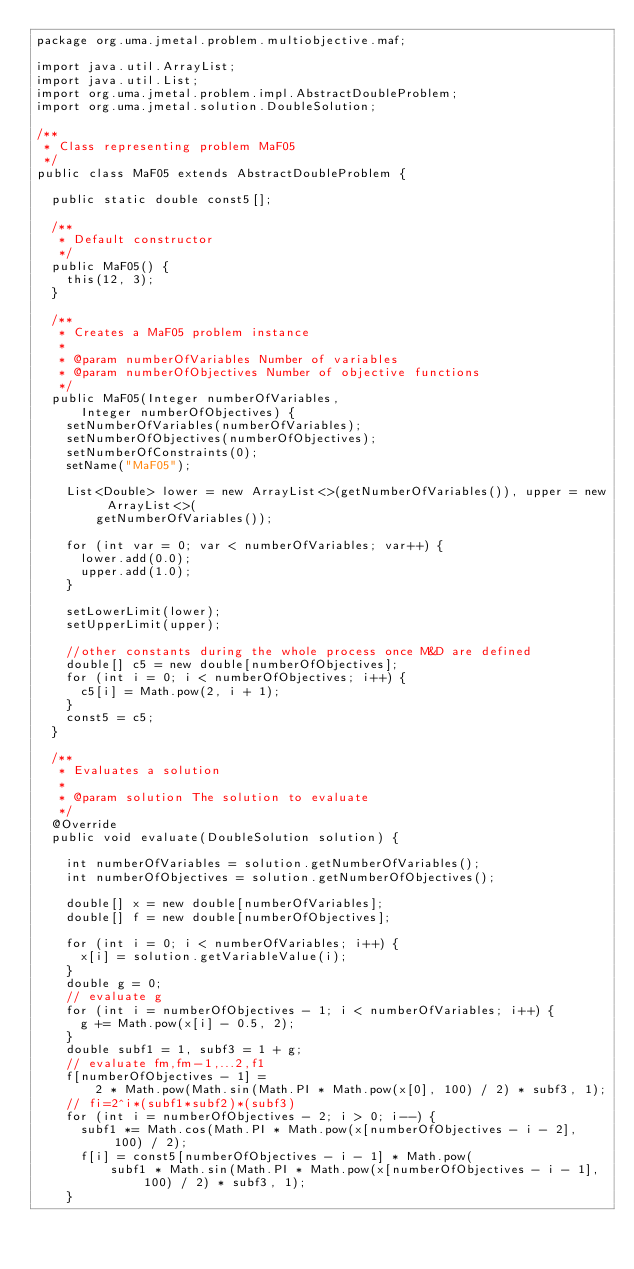Convert code to text. <code><loc_0><loc_0><loc_500><loc_500><_Java_>package org.uma.jmetal.problem.multiobjective.maf;

import java.util.ArrayList;
import java.util.List;
import org.uma.jmetal.problem.impl.AbstractDoubleProblem;
import org.uma.jmetal.solution.DoubleSolution;

/**
 * Class representing problem MaF05
 */
public class MaF05 extends AbstractDoubleProblem {

  public static double const5[];

  /**
   * Default constructor
   */
  public MaF05() {
    this(12, 3);
  }

  /**
   * Creates a MaF05 problem instance
   *
   * @param numberOfVariables Number of variables
   * @param numberOfObjectives Number of objective functions
   */
  public MaF05(Integer numberOfVariables,
      Integer numberOfObjectives) {
    setNumberOfVariables(numberOfVariables);
    setNumberOfObjectives(numberOfObjectives);
    setNumberOfConstraints(0);
    setName("MaF05");

    List<Double> lower = new ArrayList<>(getNumberOfVariables()), upper = new ArrayList<>(
        getNumberOfVariables());

    for (int var = 0; var < numberOfVariables; var++) {
      lower.add(0.0);
      upper.add(1.0);
    }

    setLowerLimit(lower);
    setUpperLimit(upper);

    //other constants during the whole process once M&D are defined
    double[] c5 = new double[numberOfObjectives];
    for (int i = 0; i < numberOfObjectives; i++) {
      c5[i] = Math.pow(2, i + 1);
    }
    const5 = c5;
  }

  /**
   * Evaluates a solution
   *
   * @param solution The solution to evaluate
   */
  @Override
  public void evaluate(DoubleSolution solution) {

    int numberOfVariables = solution.getNumberOfVariables();
    int numberOfObjectives = solution.getNumberOfObjectives();

    double[] x = new double[numberOfVariables];
    double[] f = new double[numberOfObjectives];

    for (int i = 0; i < numberOfVariables; i++) {
      x[i] = solution.getVariableValue(i);
    }
    double g = 0;
    // evaluate g
    for (int i = numberOfObjectives - 1; i < numberOfVariables; i++) {
      g += Math.pow(x[i] - 0.5, 2);
    }
    double subf1 = 1, subf3 = 1 + g;
    // evaluate fm,fm-1,...2,f1
    f[numberOfObjectives - 1] =
        2 * Math.pow(Math.sin(Math.PI * Math.pow(x[0], 100) / 2) * subf3, 1);
    // fi=2^i*(subf1*subf2)*(subf3)
    for (int i = numberOfObjectives - 2; i > 0; i--) {
      subf1 *= Math.cos(Math.PI * Math.pow(x[numberOfObjectives - i - 2], 100) / 2);
      f[i] = const5[numberOfObjectives - i - 1] * Math.pow(
          subf1 * Math.sin(Math.PI * Math.pow(x[numberOfObjectives - i - 1], 100) / 2) * subf3, 1);
    }</code> 